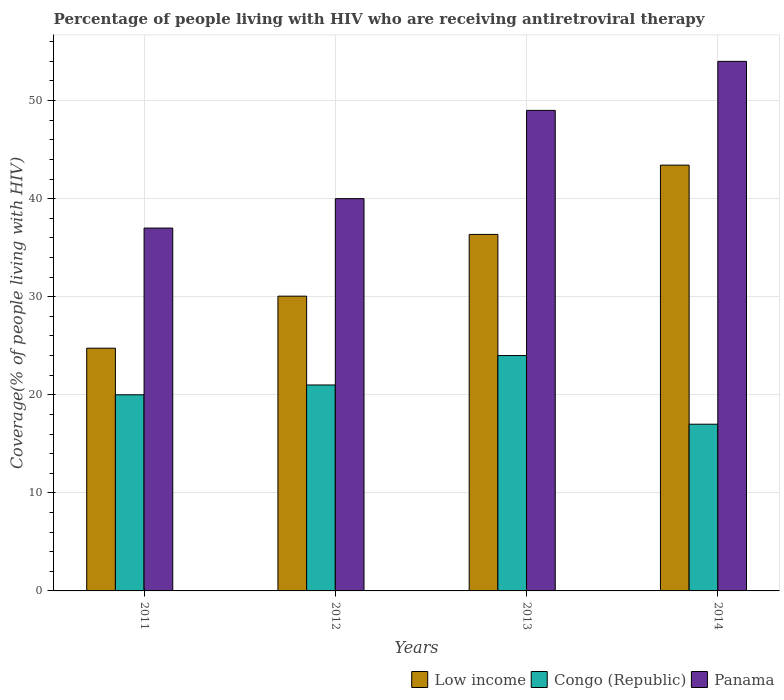Are the number of bars per tick equal to the number of legend labels?
Keep it short and to the point. Yes. Are the number of bars on each tick of the X-axis equal?
Offer a terse response. Yes. What is the percentage of the HIV infected people who are receiving antiretroviral therapy in Congo (Republic) in 2014?
Offer a terse response. 17. Across all years, what is the maximum percentage of the HIV infected people who are receiving antiretroviral therapy in Panama?
Make the answer very short. 54. Across all years, what is the minimum percentage of the HIV infected people who are receiving antiretroviral therapy in Panama?
Your answer should be compact. 37. In which year was the percentage of the HIV infected people who are receiving antiretroviral therapy in Congo (Republic) maximum?
Provide a succinct answer. 2013. In which year was the percentage of the HIV infected people who are receiving antiretroviral therapy in Low income minimum?
Your response must be concise. 2011. What is the total percentage of the HIV infected people who are receiving antiretroviral therapy in Low income in the graph?
Keep it short and to the point. 134.58. What is the difference between the percentage of the HIV infected people who are receiving antiretroviral therapy in Panama in 2012 and that in 2014?
Your response must be concise. -14. What is the difference between the percentage of the HIV infected people who are receiving antiretroviral therapy in Congo (Republic) in 2011 and the percentage of the HIV infected people who are receiving antiretroviral therapy in Low income in 2012?
Provide a short and direct response. -10.06. What is the average percentage of the HIV infected people who are receiving antiretroviral therapy in Low income per year?
Offer a very short reply. 33.64. In the year 2013, what is the difference between the percentage of the HIV infected people who are receiving antiretroviral therapy in Panama and percentage of the HIV infected people who are receiving antiretroviral therapy in Congo (Republic)?
Provide a short and direct response. 25. What is the ratio of the percentage of the HIV infected people who are receiving antiretroviral therapy in Low income in 2012 to that in 2014?
Your answer should be very brief. 0.69. Is the difference between the percentage of the HIV infected people who are receiving antiretroviral therapy in Panama in 2011 and 2014 greater than the difference between the percentage of the HIV infected people who are receiving antiretroviral therapy in Congo (Republic) in 2011 and 2014?
Make the answer very short. No. What is the difference between the highest and the lowest percentage of the HIV infected people who are receiving antiretroviral therapy in Congo (Republic)?
Make the answer very short. 7. Is the sum of the percentage of the HIV infected people who are receiving antiretroviral therapy in Congo (Republic) in 2011 and 2013 greater than the maximum percentage of the HIV infected people who are receiving antiretroviral therapy in Low income across all years?
Provide a short and direct response. Yes. What does the 2nd bar from the left in 2014 represents?
Give a very brief answer. Congo (Republic). What does the 2nd bar from the right in 2013 represents?
Provide a short and direct response. Congo (Republic). Is it the case that in every year, the sum of the percentage of the HIV infected people who are receiving antiretroviral therapy in Low income and percentage of the HIV infected people who are receiving antiretroviral therapy in Panama is greater than the percentage of the HIV infected people who are receiving antiretroviral therapy in Congo (Republic)?
Your answer should be very brief. Yes. Are all the bars in the graph horizontal?
Provide a succinct answer. No. Does the graph contain any zero values?
Offer a terse response. No. Where does the legend appear in the graph?
Keep it short and to the point. Bottom right. What is the title of the graph?
Keep it short and to the point. Percentage of people living with HIV who are receiving antiretroviral therapy. What is the label or title of the Y-axis?
Ensure brevity in your answer.  Coverage(% of people living with HIV). What is the Coverage(% of people living with HIV) of Low income in 2011?
Provide a short and direct response. 24.75. What is the Coverage(% of people living with HIV) in Congo (Republic) in 2011?
Offer a very short reply. 20. What is the Coverage(% of people living with HIV) in Panama in 2011?
Your response must be concise. 37. What is the Coverage(% of people living with HIV) in Low income in 2012?
Offer a very short reply. 30.06. What is the Coverage(% of people living with HIV) of Low income in 2013?
Provide a short and direct response. 36.35. What is the Coverage(% of people living with HIV) in Panama in 2013?
Provide a short and direct response. 49. What is the Coverage(% of people living with HIV) in Low income in 2014?
Ensure brevity in your answer.  43.42. What is the Coverage(% of people living with HIV) of Panama in 2014?
Provide a succinct answer. 54. Across all years, what is the maximum Coverage(% of people living with HIV) in Low income?
Offer a terse response. 43.42. Across all years, what is the maximum Coverage(% of people living with HIV) of Panama?
Your response must be concise. 54. Across all years, what is the minimum Coverage(% of people living with HIV) in Low income?
Make the answer very short. 24.75. Across all years, what is the minimum Coverage(% of people living with HIV) in Congo (Republic)?
Ensure brevity in your answer.  17. What is the total Coverage(% of people living with HIV) in Low income in the graph?
Your response must be concise. 134.58. What is the total Coverage(% of people living with HIV) of Congo (Republic) in the graph?
Your answer should be compact. 82. What is the total Coverage(% of people living with HIV) of Panama in the graph?
Provide a short and direct response. 180. What is the difference between the Coverage(% of people living with HIV) in Low income in 2011 and that in 2012?
Give a very brief answer. -5.31. What is the difference between the Coverage(% of people living with HIV) in Panama in 2011 and that in 2012?
Offer a very short reply. -3. What is the difference between the Coverage(% of people living with HIV) in Low income in 2011 and that in 2013?
Keep it short and to the point. -11.6. What is the difference between the Coverage(% of people living with HIV) of Low income in 2011 and that in 2014?
Your answer should be compact. -18.67. What is the difference between the Coverage(% of people living with HIV) of Congo (Republic) in 2011 and that in 2014?
Provide a short and direct response. 3. What is the difference between the Coverage(% of people living with HIV) in Panama in 2011 and that in 2014?
Your response must be concise. -17. What is the difference between the Coverage(% of people living with HIV) in Low income in 2012 and that in 2013?
Ensure brevity in your answer.  -6.3. What is the difference between the Coverage(% of people living with HIV) in Congo (Republic) in 2012 and that in 2013?
Provide a succinct answer. -3. What is the difference between the Coverage(% of people living with HIV) in Panama in 2012 and that in 2013?
Give a very brief answer. -9. What is the difference between the Coverage(% of people living with HIV) of Low income in 2012 and that in 2014?
Provide a succinct answer. -13.36. What is the difference between the Coverage(% of people living with HIV) in Congo (Republic) in 2012 and that in 2014?
Keep it short and to the point. 4. What is the difference between the Coverage(% of people living with HIV) of Low income in 2013 and that in 2014?
Provide a short and direct response. -7.06. What is the difference between the Coverage(% of people living with HIV) of Congo (Republic) in 2013 and that in 2014?
Make the answer very short. 7. What is the difference between the Coverage(% of people living with HIV) in Panama in 2013 and that in 2014?
Provide a short and direct response. -5. What is the difference between the Coverage(% of people living with HIV) of Low income in 2011 and the Coverage(% of people living with HIV) of Congo (Republic) in 2012?
Make the answer very short. 3.75. What is the difference between the Coverage(% of people living with HIV) of Low income in 2011 and the Coverage(% of people living with HIV) of Panama in 2012?
Give a very brief answer. -15.25. What is the difference between the Coverage(% of people living with HIV) in Congo (Republic) in 2011 and the Coverage(% of people living with HIV) in Panama in 2012?
Your response must be concise. -20. What is the difference between the Coverage(% of people living with HIV) of Low income in 2011 and the Coverage(% of people living with HIV) of Panama in 2013?
Ensure brevity in your answer.  -24.25. What is the difference between the Coverage(% of people living with HIV) in Congo (Republic) in 2011 and the Coverage(% of people living with HIV) in Panama in 2013?
Your response must be concise. -29. What is the difference between the Coverage(% of people living with HIV) in Low income in 2011 and the Coverage(% of people living with HIV) in Congo (Republic) in 2014?
Give a very brief answer. 7.75. What is the difference between the Coverage(% of people living with HIV) of Low income in 2011 and the Coverage(% of people living with HIV) of Panama in 2014?
Give a very brief answer. -29.25. What is the difference between the Coverage(% of people living with HIV) in Congo (Republic) in 2011 and the Coverage(% of people living with HIV) in Panama in 2014?
Provide a short and direct response. -34. What is the difference between the Coverage(% of people living with HIV) of Low income in 2012 and the Coverage(% of people living with HIV) of Congo (Republic) in 2013?
Ensure brevity in your answer.  6.06. What is the difference between the Coverage(% of people living with HIV) in Low income in 2012 and the Coverage(% of people living with HIV) in Panama in 2013?
Ensure brevity in your answer.  -18.94. What is the difference between the Coverage(% of people living with HIV) in Low income in 2012 and the Coverage(% of people living with HIV) in Congo (Republic) in 2014?
Ensure brevity in your answer.  13.06. What is the difference between the Coverage(% of people living with HIV) in Low income in 2012 and the Coverage(% of people living with HIV) in Panama in 2014?
Provide a short and direct response. -23.94. What is the difference between the Coverage(% of people living with HIV) of Congo (Republic) in 2012 and the Coverage(% of people living with HIV) of Panama in 2014?
Make the answer very short. -33. What is the difference between the Coverage(% of people living with HIV) in Low income in 2013 and the Coverage(% of people living with HIV) in Congo (Republic) in 2014?
Provide a succinct answer. 19.35. What is the difference between the Coverage(% of people living with HIV) in Low income in 2013 and the Coverage(% of people living with HIV) in Panama in 2014?
Provide a short and direct response. -17.65. What is the average Coverage(% of people living with HIV) in Low income per year?
Offer a terse response. 33.64. In the year 2011, what is the difference between the Coverage(% of people living with HIV) of Low income and Coverage(% of people living with HIV) of Congo (Republic)?
Your response must be concise. 4.75. In the year 2011, what is the difference between the Coverage(% of people living with HIV) of Low income and Coverage(% of people living with HIV) of Panama?
Your answer should be very brief. -12.25. In the year 2011, what is the difference between the Coverage(% of people living with HIV) of Congo (Republic) and Coverage(% of people living with HIV) of Panama?
Provide a succinct answer. -17. In the year 2012, what is the difference between the Coverage(% of people living with HIV) of Low income and Coverage(% of people living with HIV) of Congo (Republic)?
Offer a very short reply. 9.06. In the year 2012, what is the difference between the Coverage(% of people living with HIV) of Low income and Coverage(% of people living with HIV) of Panama?
Your answer should be very brief. -9.94. In the year 2013, what is the difference between the Coverage(% of people living with HIV) of Low income and Coverage(% of people living with HIV) of Congo (Republic)?
Provide a succinct answer. 12.35. In the year 2013, what is the difference between the Coverage(% of people living with HIV) of Low income and Coverage(% of people living with HIV) of Panama?
Your answer should be compact. -12.65. In the year 2014, what is the difference between the Coverage(% of people living with HIV) of Low income and Coverage(% of people living with HIV) of Congo (Republic)?
Keep it short and to the point. 26.42. In the year 2014, what is the difference between the Coverage(% of people living with HIV) in Low income and Coverage(% of people living with HIV) in Panama?
Ensure brevity in your answer.  -10.58. In the year 2014, what is the difference between the Coverage(% of people living with HIV) of Congo (Republic) and Coverage(% of people living with HIV) of Panama?
Provide a short and direct response. -37. What is the ratio of the Coverage(% of people living with HIV) of Low income in 2011 to that in 2012?
Your answer should be very brief. 0.82. What is the ratio of the Coverage(% of people living with HIV) of Congo (Republic) in 2011 to that in 2012?
Provide a succinct answer. 0.95. What is the ratio of the Coverage(% of people living with HIV) of Panama in 2011 to that in 2012?
Your answer should be compact. 0.93. What is the ratio of the Coverage(% of people living with HIV) in Low income in 2011 to that in 2013?
Keep it short and to the point. 0.68. What is the ratio of the Coverage(% of people living with HIV) of Congo (Republic) in 2011 to that in 2013?
Your answer should be compact. 0.83. What is the ratio of the Coverage(% of people living with HIV) in Panama in 2011 to that in 2013?
Offer a very short reply. 0.76. What is the ratio of the Coverage(% of people living with HIV) in Low income in 2011 to that in 2014?
Ensure brevity in your answer.  0.57. What is the ratio of the Coverage(% of people living with HIV) in Congo (Republic) in 2011 to that in 2014?
Offer a very short reply. 1.18. What is the ratio of the Coverage(% of people living with HIV) in Panama in 2011 to that in 2014?
Offer a terse response. 0.69. What is the ratio of the Coverage(% of people living with HIV) in Low income in 2012 to that in 2013?
Your response must be concise. 0.83. What is the ratio of the Coverage(% of people living with HIV) in Panama in 2012 to that in 2013?
Keep it short and to the point. 0.82. What is the ratio of the Coverage(% of people living with HIV) of Low income in 2012 to that in 2014?
Keep it short and to the point. 0.69. What is the ratio of the Coverage(% of people living with HIV) of Congo (Republic) in 2012 to that in 2014?
Offer a terse response. 1.24. What is the ratio of the Coverage(% of people living with HIV) of Panama in 2012 to that in 2014?
Give a very brief answer. 0.74. What is the ratio of the Coverage(% of people living with HIV) of Low income in 2013 to that in 2014?
Your response must be concise. 0.84. What is the ratio of the Coverage(% of people living with HIV) of Congo (Republic) in 2013 to that in 2014?
Give a very brief answer. 1.41. What is the ratio of the Coverage(% of people living with HIV) of Panama in 2013 to that in 2014?
Your answer should be compact. 0.91. What is the difference between the highest and the second highest Coverage(% of people living with HIV) in Low income?
Offer a very short reply. 7.06. What is the difference between the highest and the second highest Coverage(% of people living with HIV) in Congo (Republic)?
Your answer should be compact. 3. What is the difference between the highest and the second highest Coverage(% of people living with HIV) in Panama?
Offer a very short reply. 5. What is the difference between the highest and the lowest Coverage(% of people living with HIV) of Low income?
Provide a short and direct response. 18.67. What is the difference between the highest and the lowest Coverage(% of people living with HIV) in Congo (Republic)?
Provide a short and direct response. 7. 